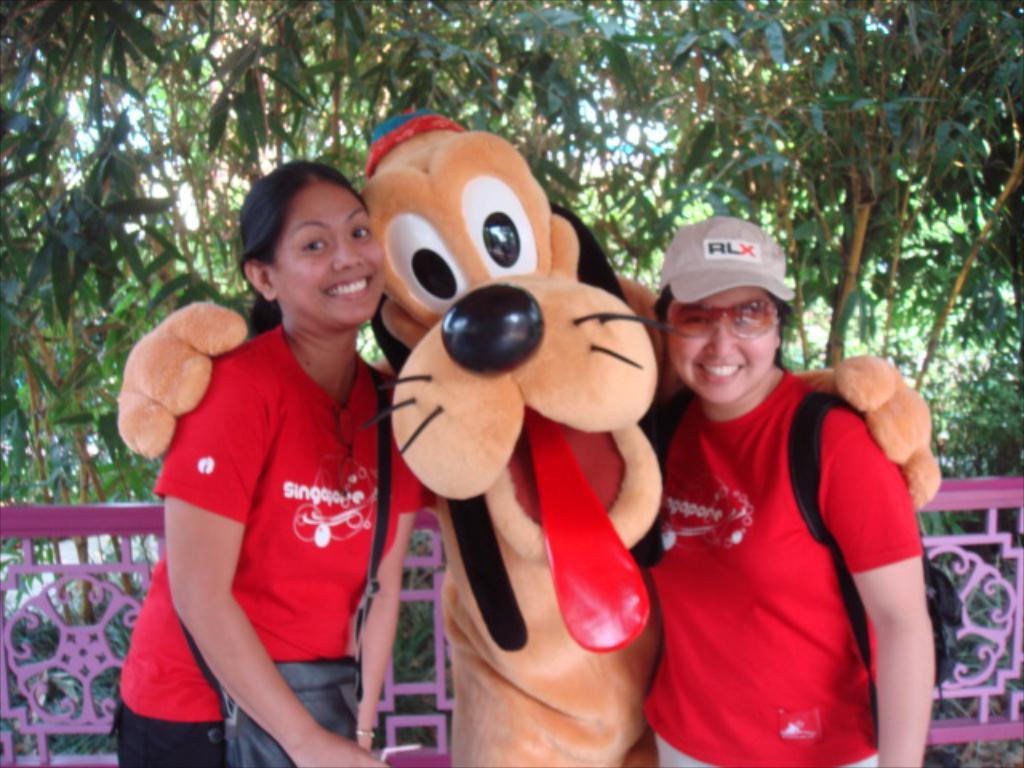Who are the main subjects in the image? There are two ladies in the center of the image. What else can be seen in the image besides the ladies? There is a depiction of a cartoon in the image. What type of natural scenery is visible in the background? There are trees in the background of the image. What architectural feature can be seen in the image? There is railing visible in the image. How many fish are swimming in the drawer in the image? There are no fish or drawers present in the image. 